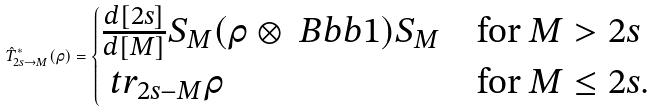<formula> <loc_0><loc_0><loc_500><loc_500>\hat { T } ^ { * } _ { 2 s \to M } ( \rho ) = \begin{cases} \frac { d [ 2 s ] } { d [ M ] } S _ { M } ( \rho \otimes \ B b b { 1 } ) S _ { M } & \text {for} \ M > 2 s \\ \ t r _ { 2 s - M } \rho & \text {for} \ M \leq 2 s . \end{cases}</formula> 